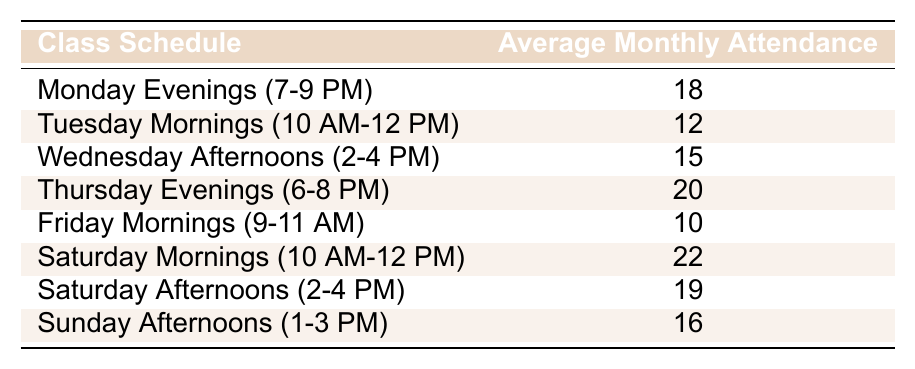What is the average monthly attendance for the ceramics class on Thursday evenings? The table shows that the average monthly attendance for Thursday Evenings (6-8 PM) is 20.
Answer: 20 Which class schedule has the highest average monthly attendance? By reviewing the table, Saturday Mornings (10 AM-12 PM) has the highest attendance at 22.
Answer: Saturday Mornings (10 AM-12 PM) What is the average monthly attendance for the classes scheduled on weekends? The weekend classes are Saturday Mornings (22), Saturday Afternoons (19), and Sunday Afternoons (16). The sum of their attendances is 22 + 19 + 16 = 57. Dividing by the number of classes (3) gives an average of 57/3 = 19.
Answer: 19 Is the average attendance for Monday evenings higher than that for Tuesday mornings? The average for Monday Evenings is 18, and for Tuesday Mornings, it is 12. Since 18 is greater than 12, the statement is true.
Answer: Yes What is the difference in average monthly attendance between the highest and lowest attended classes? The highest attendance is for Saturday Mornings at 22, and the lowest is for Friday Mornings at 10. The difference is 22 - 10 = 12.
Answer: 12 How many classes have an average monthly attendance of 15 or higher? The classes with attendance of 15 or higher are Monday Evenings (18), Wednesday Afternoons (15), Thursday Evenings (20), Saturday Mornings (22), Saturday Afternoons (19), and Sunday Afternoons (16). This makes a total of 6 classes.
Answer: 6 What is the average of the attendances for the Tuesday and Friday morning classes? The attendance for Tuesday Mornings is 12, and for Friday Mornings is 10. The sum is 12 + 10 = 22, and the average is 22/2 = 11.
Answer: 11 Are there more classes scheduled in the afternoon or in the morning? There are 4 afternoon classes (Wednesday Afternoons, Saturday Afternoons, and Sunday Afternoons) and 4 morning classes (Tuesday Mornings, Friday Mornings, and Saturday Mornings). Since they are equal, the answer is no.
Answer: No What is the total monthly attendance across all class schedules? By adding up all the attendances: 18 + 12 + 15 + 20 + 10 + 22 + 19 + 16 = 122.
Answer: 122 If the attendance doubled for Thursday Evenings, what would the new attendance be? The current attendance for Thursday Evenings is 20. Doubling that gives 20 * 2 = 40.
Answer: 40 